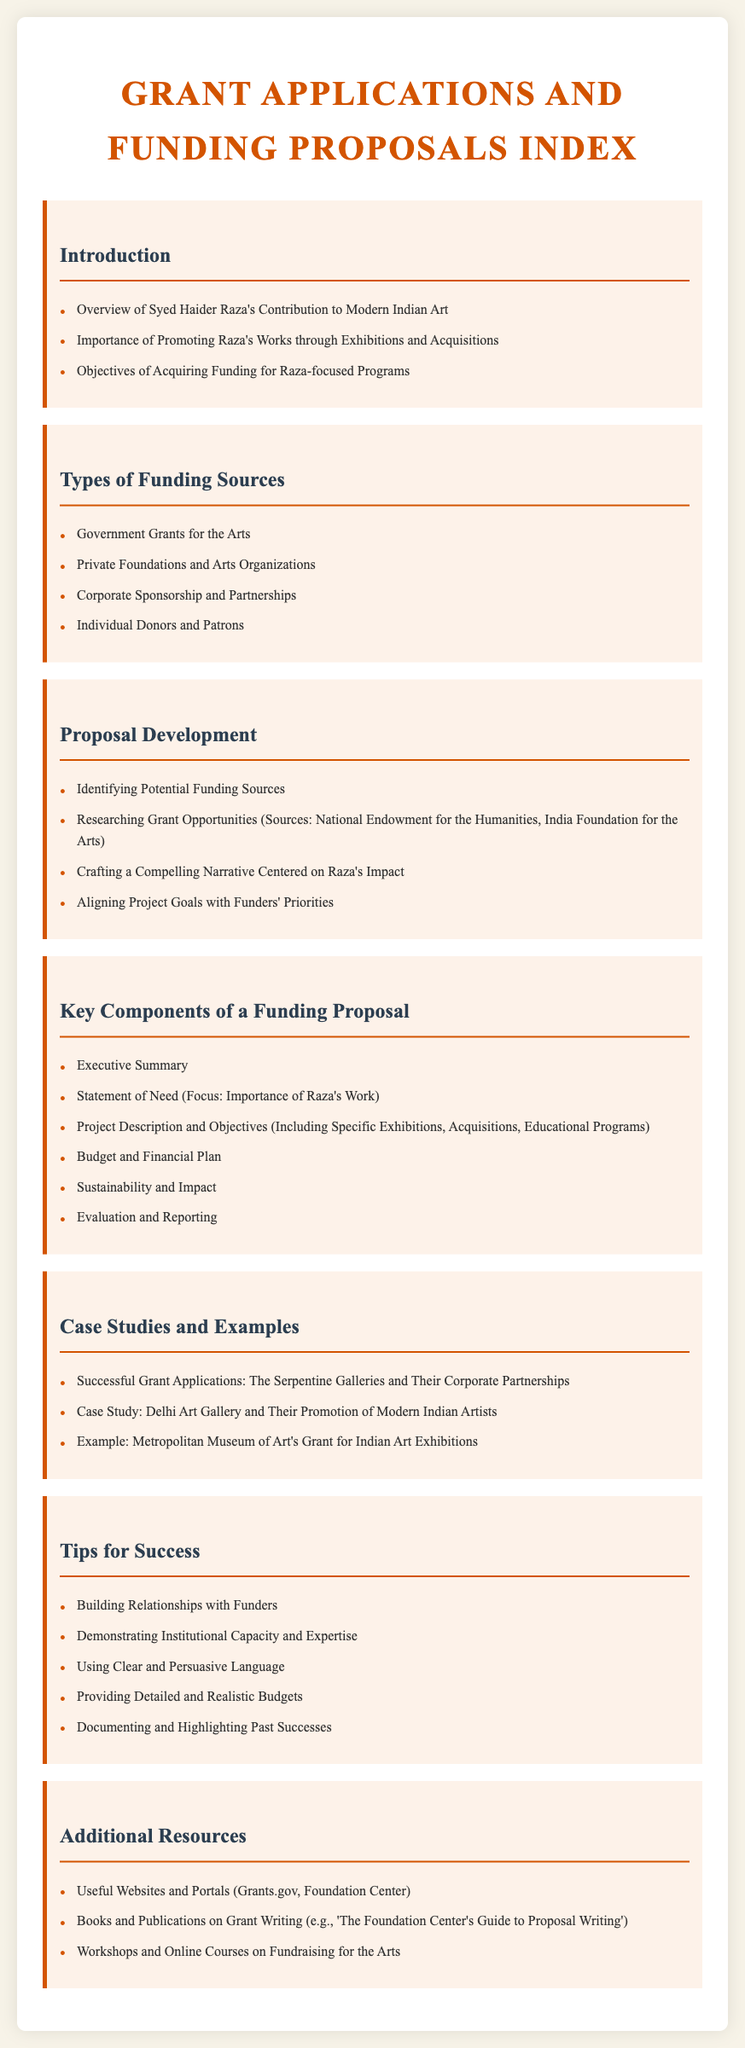What are the three types of funding sources mentioned? The document lists different types of funding sources, including government grants, private foundations, and corporate sponsorships.
Answer: Government Grants for the Arts, Private Foundations and Arts Organizations, Corporate Sponsorship and Partnerships What is the focus of the Statement of Need in a funding proposal? The Statement of Need addresses the importance of Syed Haider Raza's work in the funding proposal.
Answer: Importance of Raza's Work What constitutes a key component of a funding proposal? The document enumerates key components of a proposal, including the executive summary and project description.
Answer: Executive Summary Which organization is mentioned as an example of a successful grant application? The document provides a case study of an organization that has successfully applied for grants.
Answer: The Serpentine Galleries What is one tip for success in grant applications? Various tips for success are listed, including building relationships and using persuasive language.
Answer: Building Relationships with Funders How many sections are there in the document? The document contains seven main sections, each addressing different aspects of grant applications and funding proposals.
Answer: Seven What type of online resources does the document suggest for further learning? The document includes a section for additional resources, which suggests various online resources for grant writing.
Answer: Workshops and Online Courses on Fundraising for the Arts 